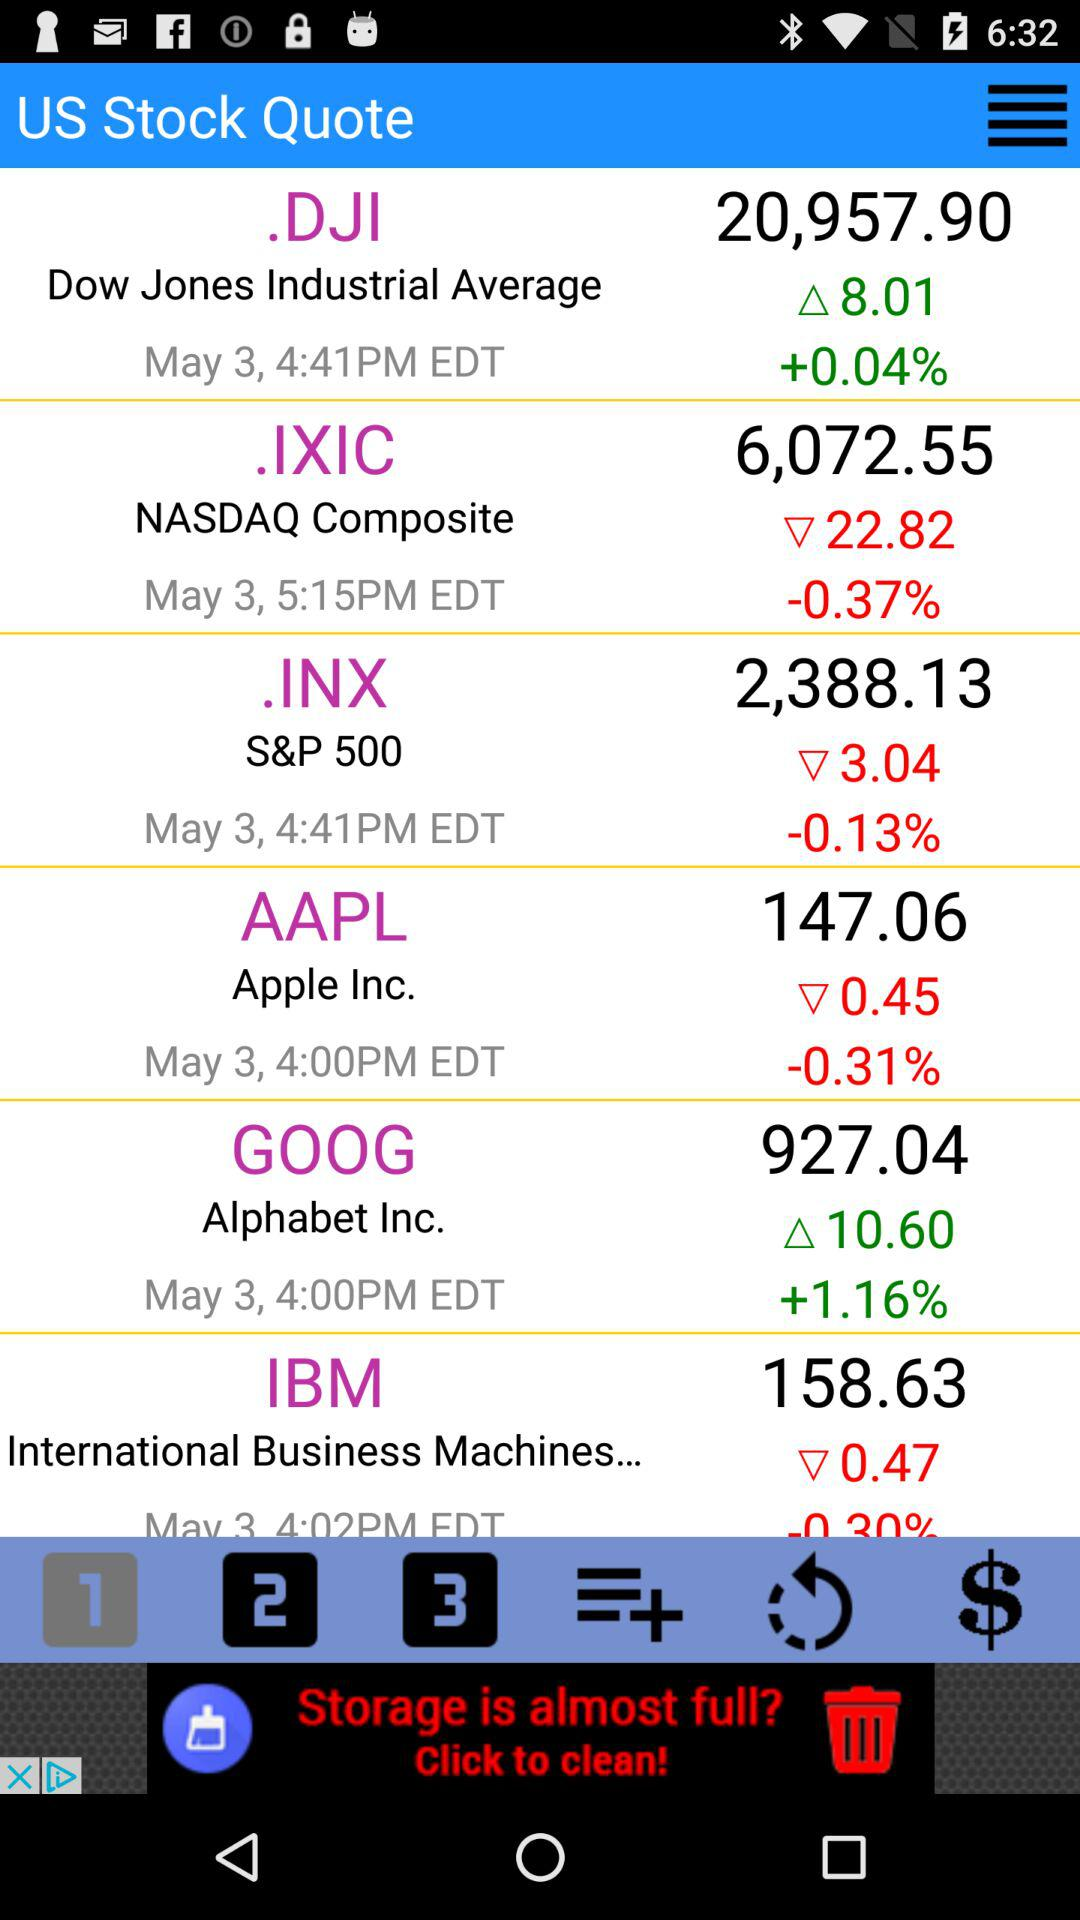What is the stock price of IBM? The stock price of IBM is 158.63. 